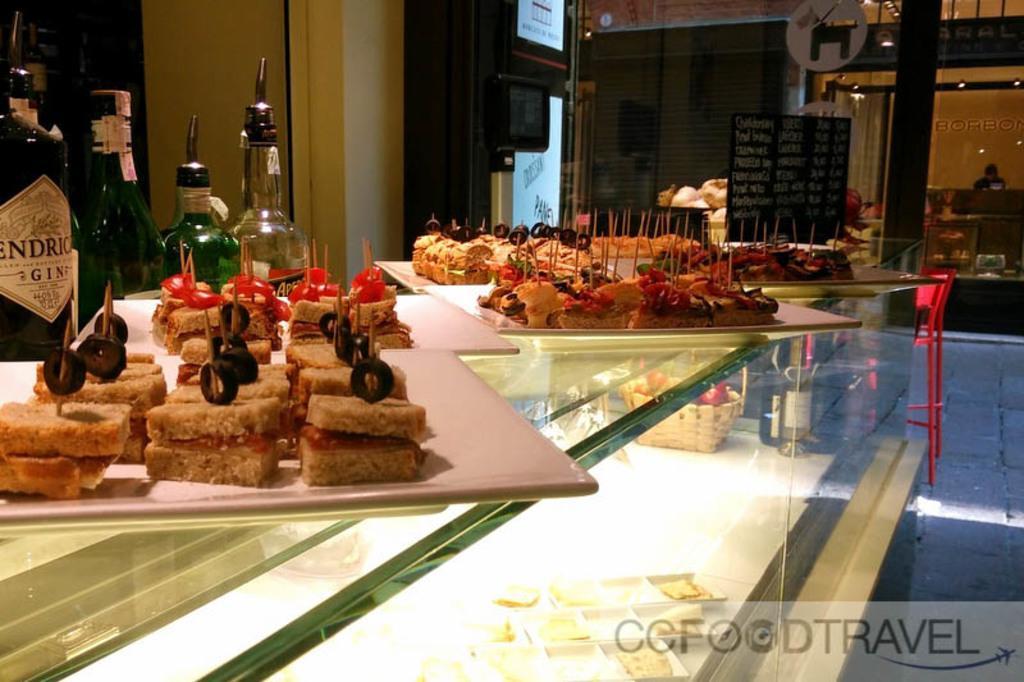Could you give a brief overview of what you see in this image? In this image we can see some food in the plates with some sticks which are placed on the table. We can also see some bottles beside them. On the backside we can see a chair, a board with some text on it, the television, a window blind, a person beside the table and some lights. 